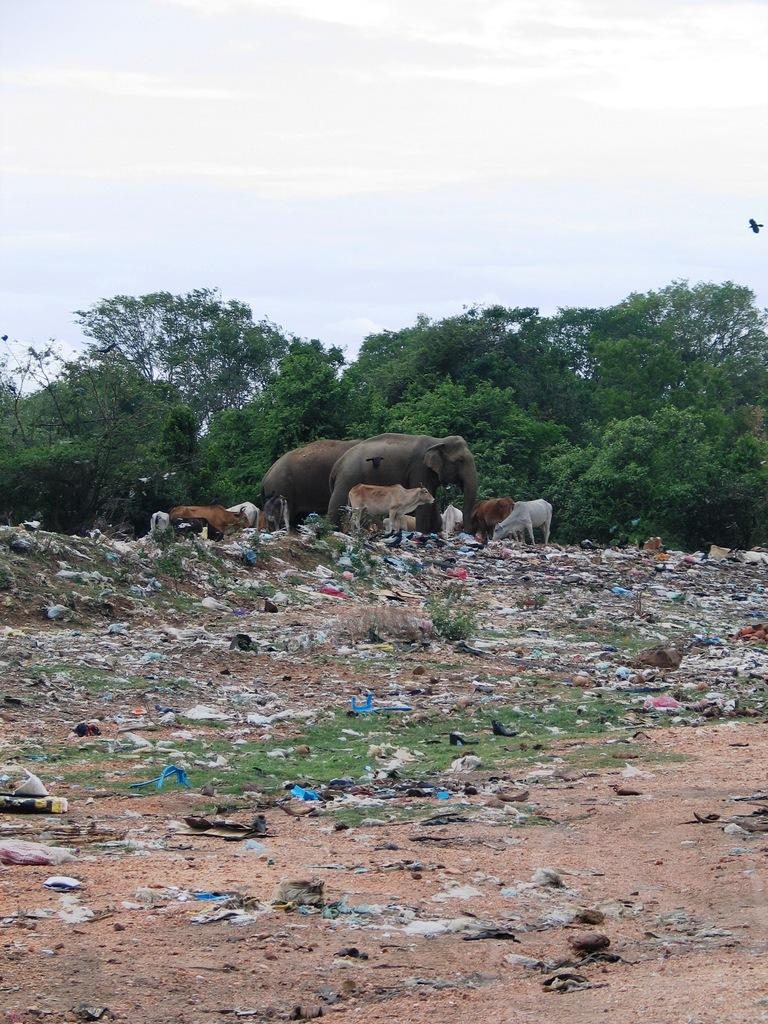What is present in the foreground of the image? There is sand, grass, and waste material in the foreground of the image. What can be seen in the middle of the image? There are animals and trees in the middle of the image. What is visible at the top of the image? The sky is visible at the top of the image. What type of knowledge is being shared by the worm in the image? There is no worm present in the image, so no knowledge can be shared by a worm. What color is the sheet covering the animals in the image? There is no sheet present in the image; the animals are not covered. 